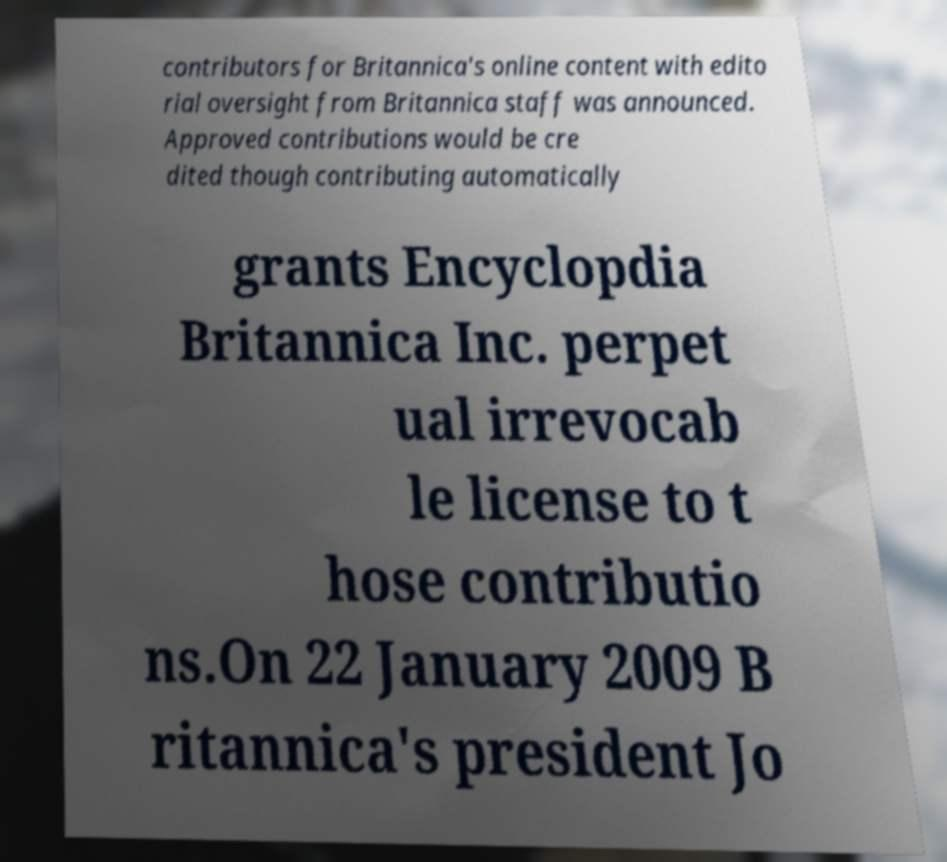Could you extract and type out the text from this image? contributors for Britannica's online content with edito rial oversight from Britannica staff was announced. Approved contributions would be cre dited though contributing automatically grants Encyclopdia Britannica Inc. perpet ual irrevocab le license to t hose contributio ns.On 22 January 2009 B ritannica's president Jo 